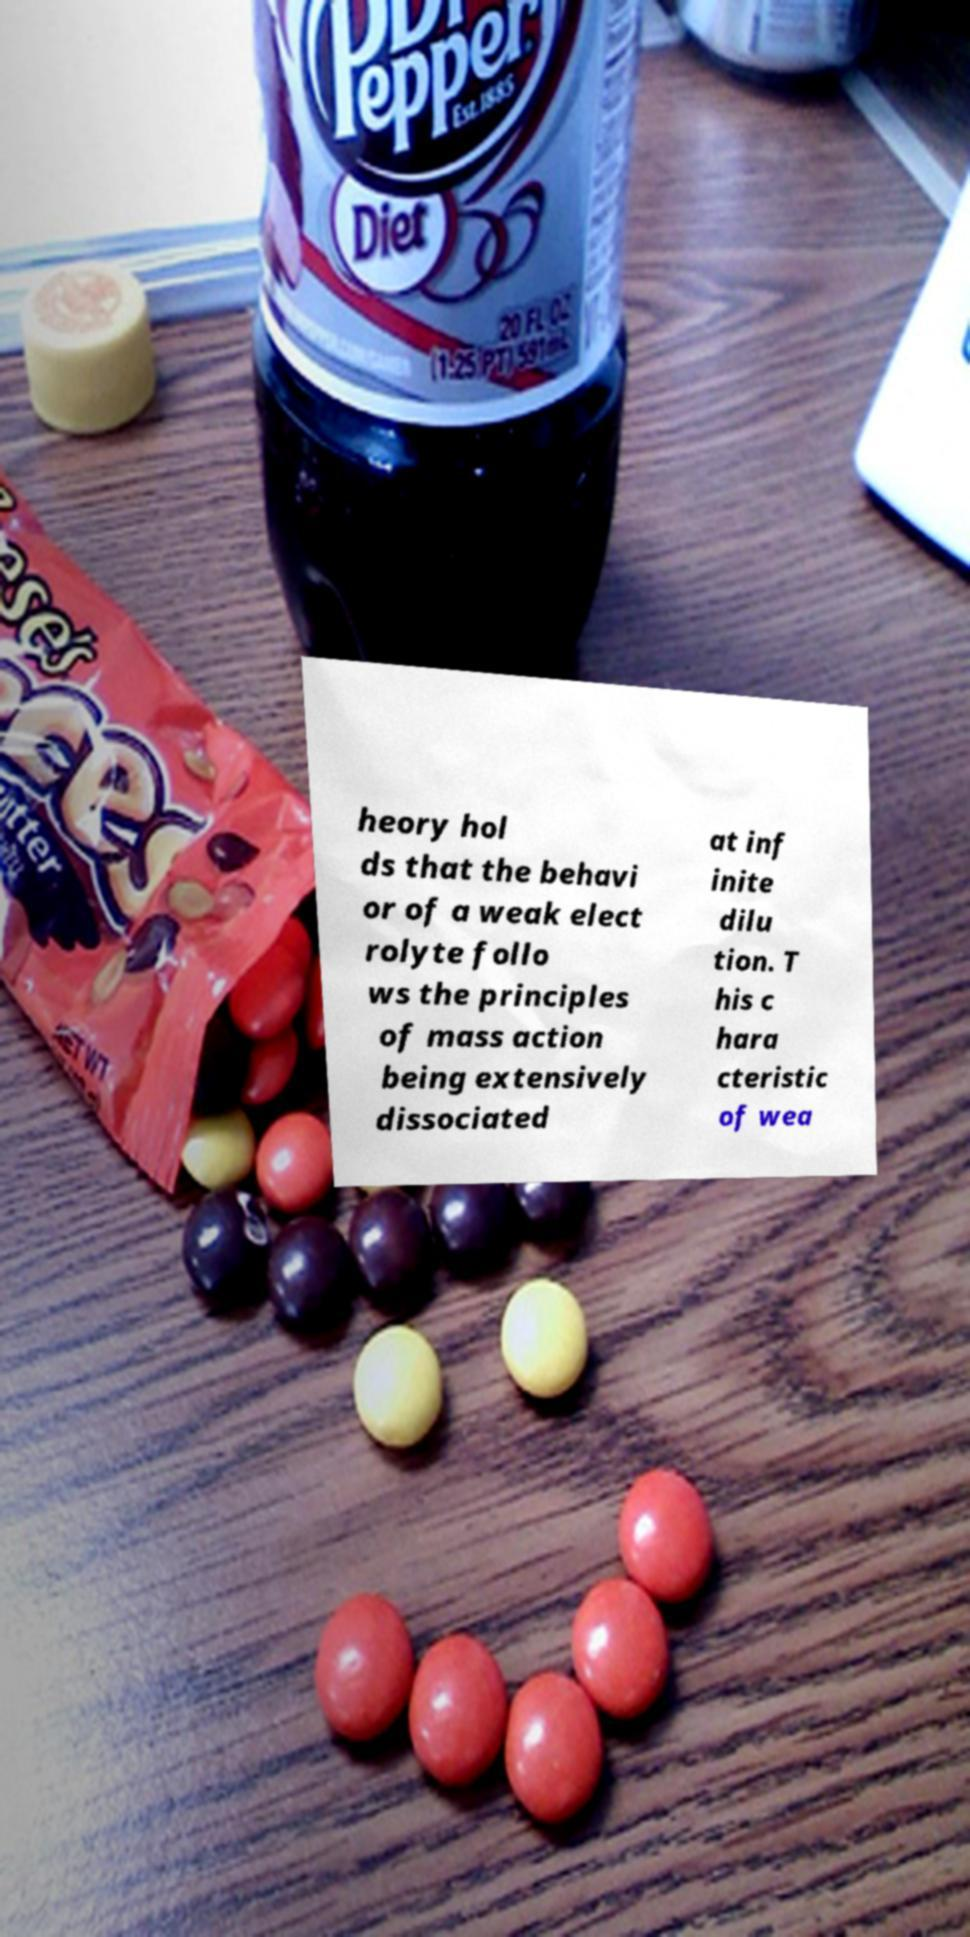Please read and relay the text visible in this image. What does it say? heory hol ds that the behavi or of a weak elect rolyte follo ws the principles of mass action being extensively dissociated at inf inite dilu tion. T his c hara cteristic of wea 